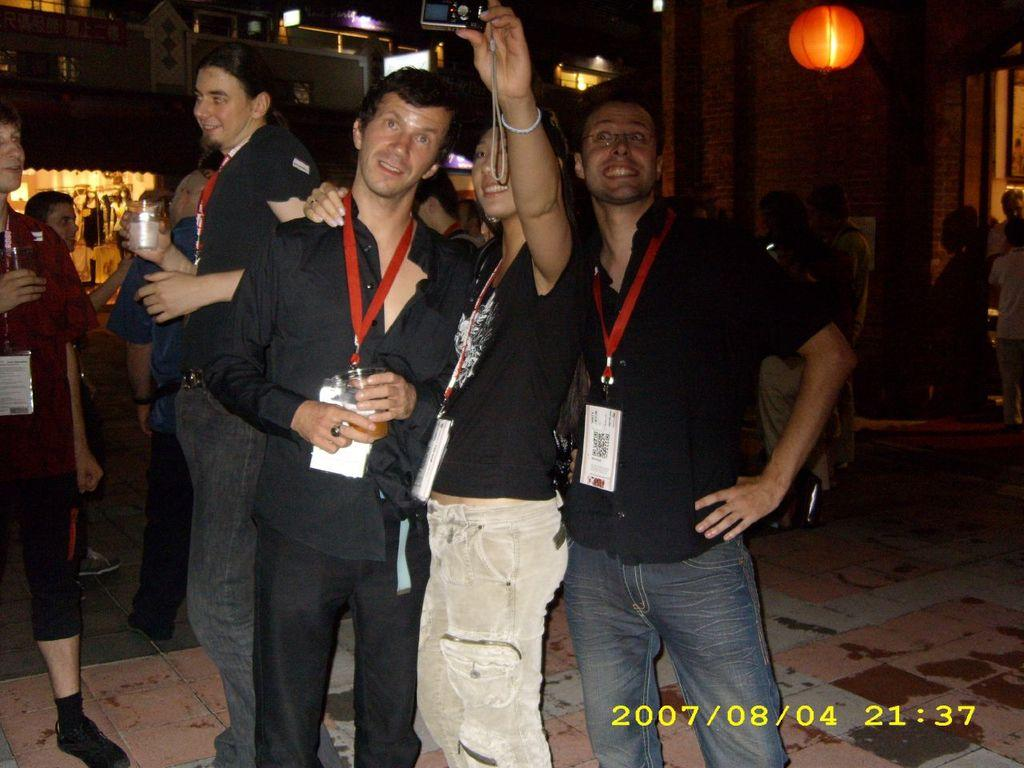How many people are in the image? There are three persons in the image. What are the three persons doing in the image? The three persons are taking a snap with a camera. What is the surface beneath the people in the image? There is a floor in the image. Are there any other people visible in the image? Yes, there are additional persons in the image. What can be seen in the distance in the image? There are buildings and lights visible in the background of the image. What type of club is being used by the persons in the image? There is no club visible in the image; the three persons are taking a snap with a camera. How does the memory of the event affect the respect for the location in the image? The image does not provide information about the event or the location, so it is not possible to determine how the memory of the event might affect the respect for the location. 